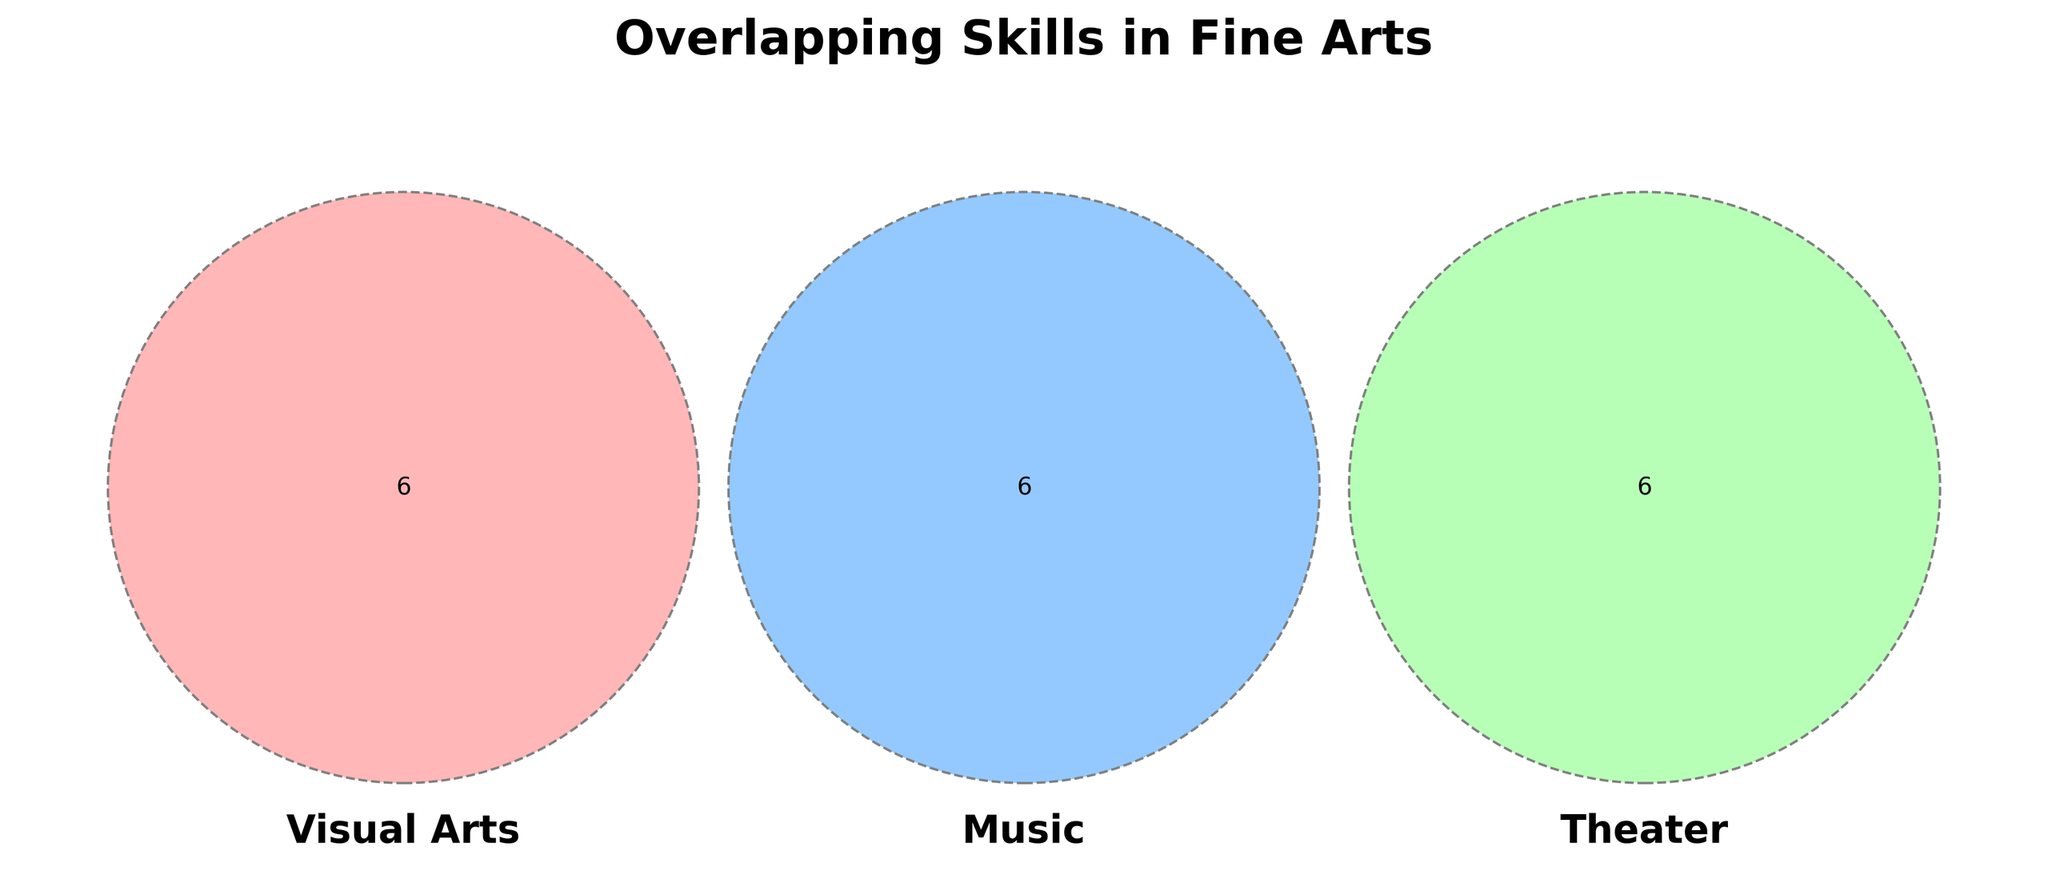What is the title of the Venn diagram? The title of the Venn diagram is displayed at the top of the figure. You can read it directly from there.
Answer: Overlapping Skills in Fine Arts Which section in the Venn diagram represents the intersection of Visual Arts and Theater only? The intersection section of Visual Arts and Theater only is the part where these two sets overlap without including Music.
Answer: Bottom left section How many skills are common to Visual Arts, Music, and Theater? The skills common to all three categories lie in the center of the Venn diagram where all three circles overlap. By counting them, we can determine the number of common skills.
Answer: 2 What skills in the diagram are unique to Music? The skills unique to Music are listed in the part of the Music circle that does not overlap with either Visual Arts or Theater.
Answer: Rhythm, Instrumentation, Sound editing, Music theory, Arrangement Which has more skills unique to it: Visual Arts or Theater? To determine this, you need to count the number of skills listed solely in the Visual Arts circle compared to those solely in the Theater circle.
Answer: Visual Arts What is the intersection of Music and Theater but not Visual Arts? This is represented by the shared area between Music and Theater circles excluding the Visual Arts circle.
Answer: Script analysis, Lighting design Which two skill sets share the skill "Portfolio development"? By reading the skills in the sections where two circles overlap, we see that “Portfolio development” is located in the common area of Visual Arts.
Answer: Visual Arts What is the most common type of skills found in the diagram? By examining the central intersection area of all three circles and the areas where only two overlap, and comparing the number of skills in each type, we can see general themes.
Answer: Creativity & Expression How does the number of skills in Visual Arts compare to those in Theater? By counting the number of skills listed in each respective circle in the Venn diagram, you can compare the total number of skills for Visual Arts and Theater.
Answer: More in Visual Arts 